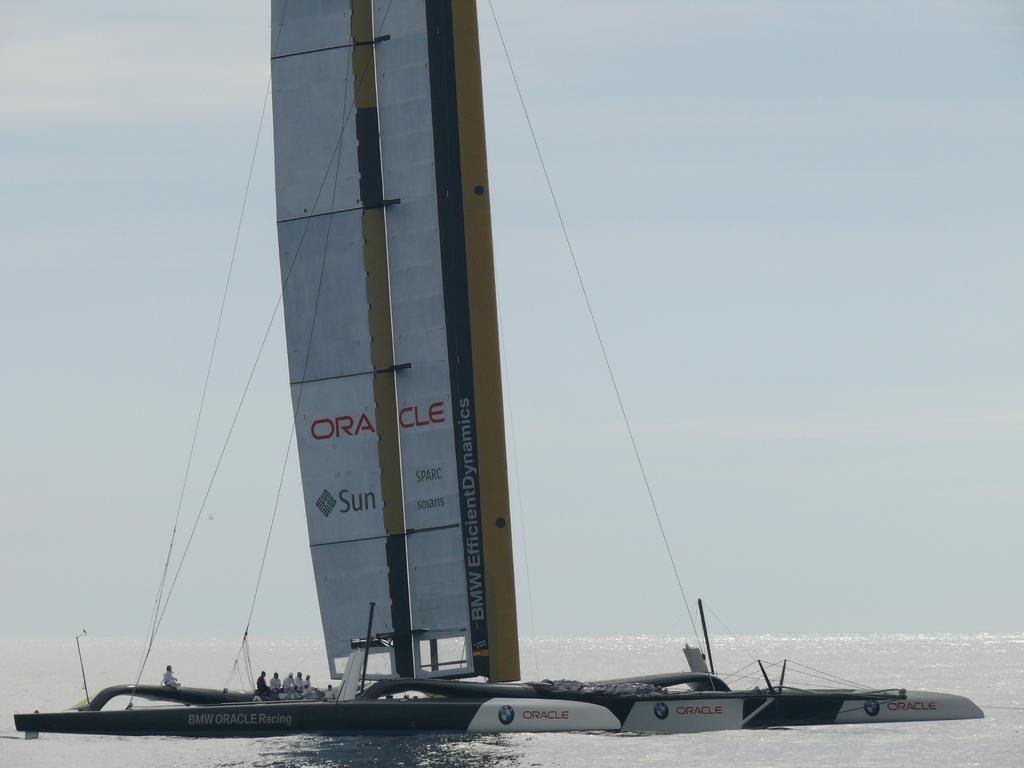Could you give a brief overview of what you see in this image? In this image I can see the boat on the water and I can see group of people in the boat. In the background the sky is in white color. 